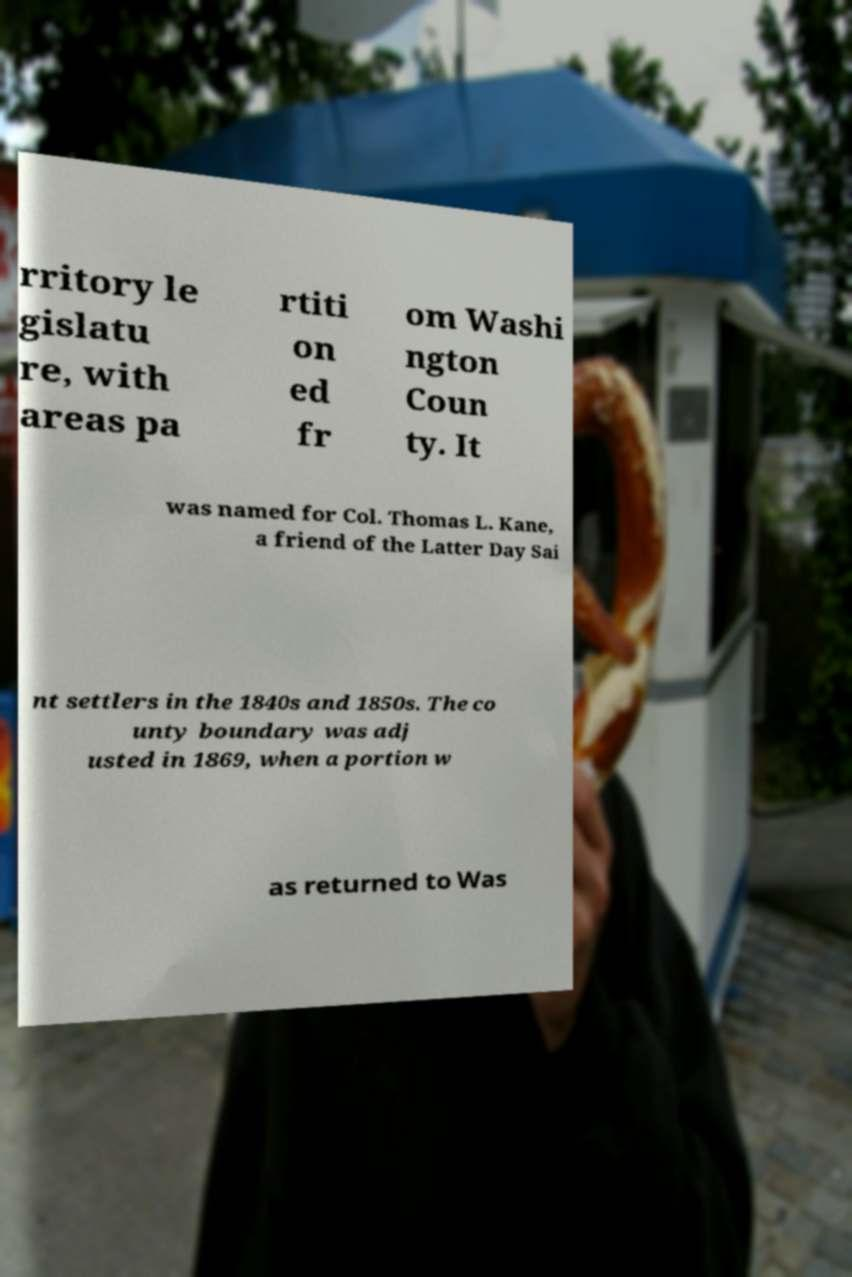What messages or text are displayed in this image? I need them in a readable, typed format. rritory le gislatu re, with areas pa rtiti on ed fr om Washi ngton Coun ty. It was named for Col. Thomas L. Kane, a friend of the Latter Day Sai nt settlers in the 1840s and 1850s. The co unty boundary was adj usted in 1869, when a portion w as returned to Was 